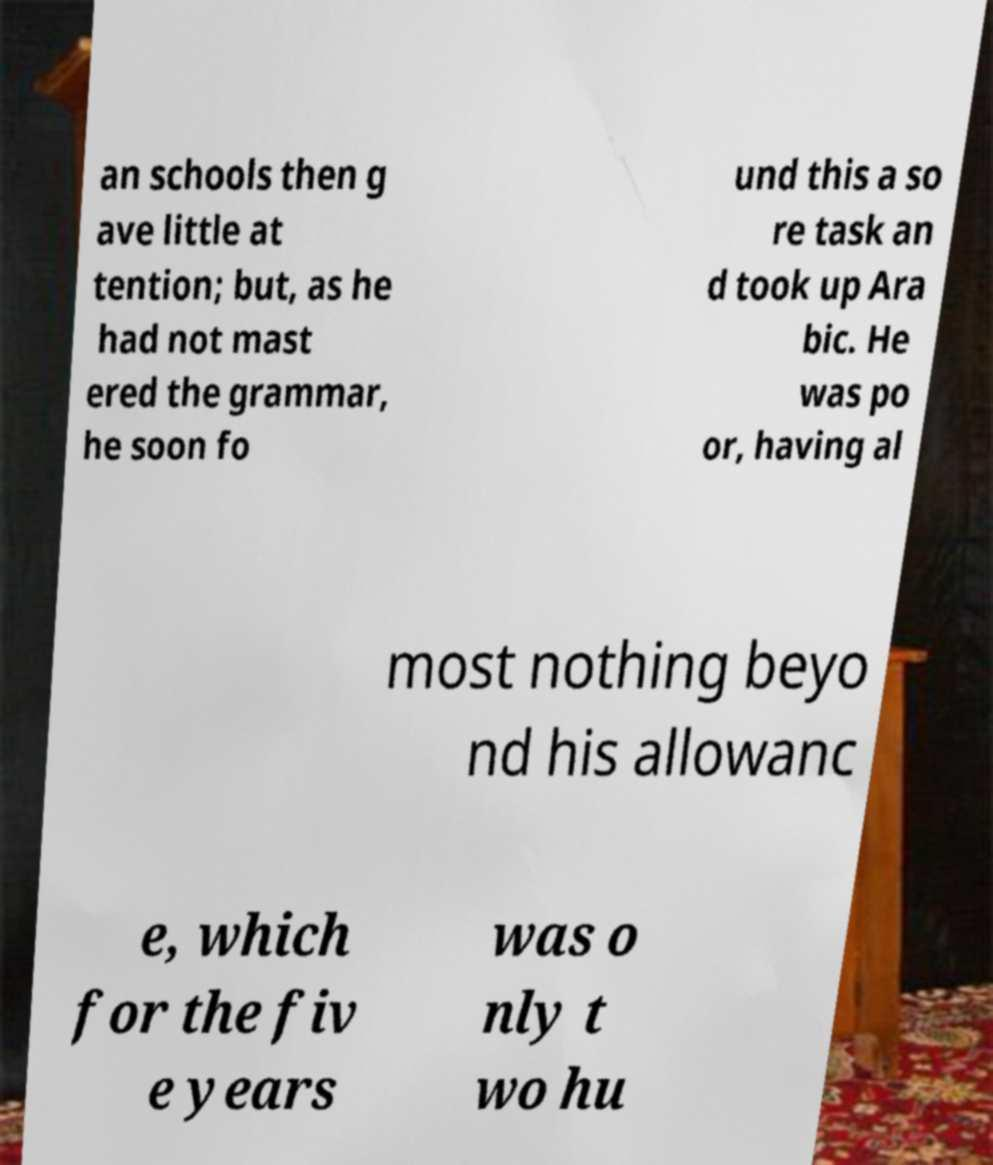Could you extract and type out the text from this image? an schools then g ave little at tention; but, as he had not mast ered the grammar, he soon fo und this a so re task an d took up Ara bic. He was po or, having al most nothing beyo nd his allowanc e, which for the fiv e years was o nly t wo hu 